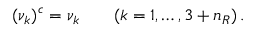<formula> <loc_0><loc_0><loc_500><loc_500>( \nu _ { k } ) ^ { c } = \nu _ { k } \quad ( k = 1 , \dots , 3 + n _ { R } ) \, .</formula> 